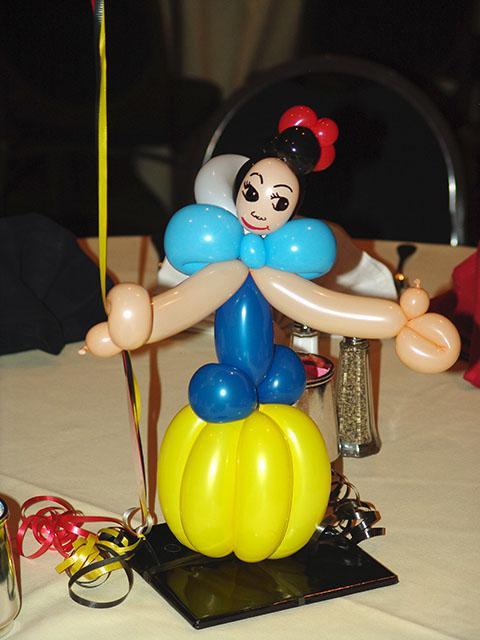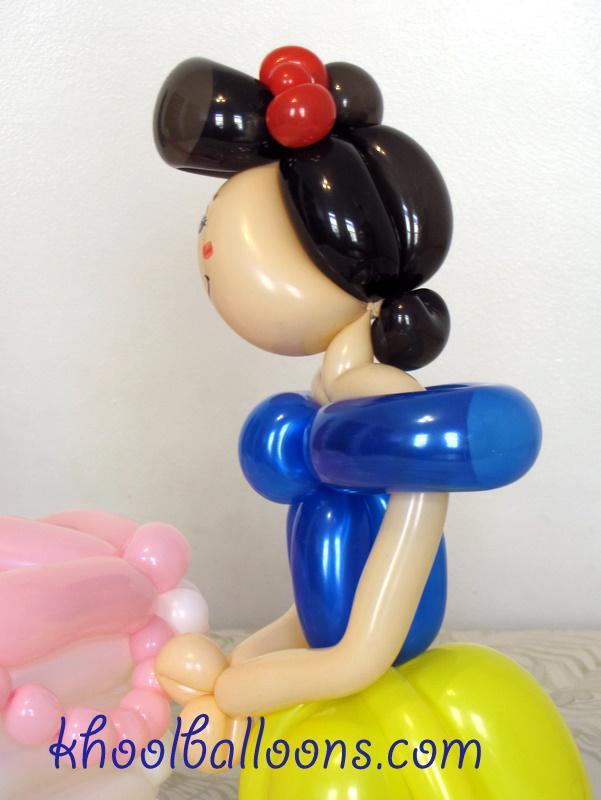The first image is the image on the left, the second image is the image on the right. Given the left and right images, does the statement "There are two princess balloon figures looking forward." hold true? Answer yes or no. No. 